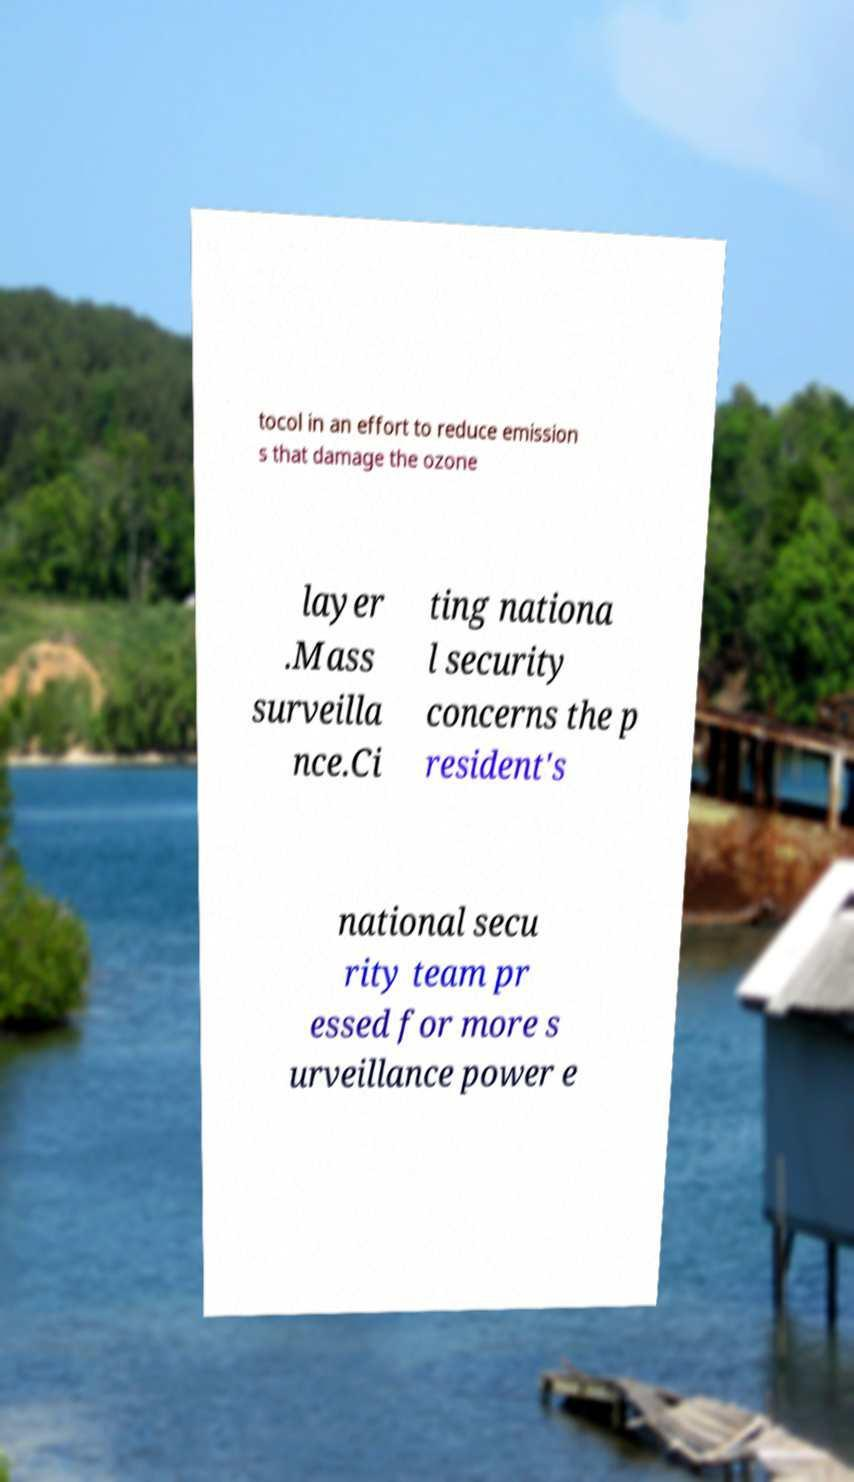Please read and relay the text visible in this image. What does it say? tocol in an effort to reduce emission s that damage the ozone layer .Mass surveilla nce.Ci ting nationa l security concerns the p resident's national secu rity team pr essed for more s urveillance power e 